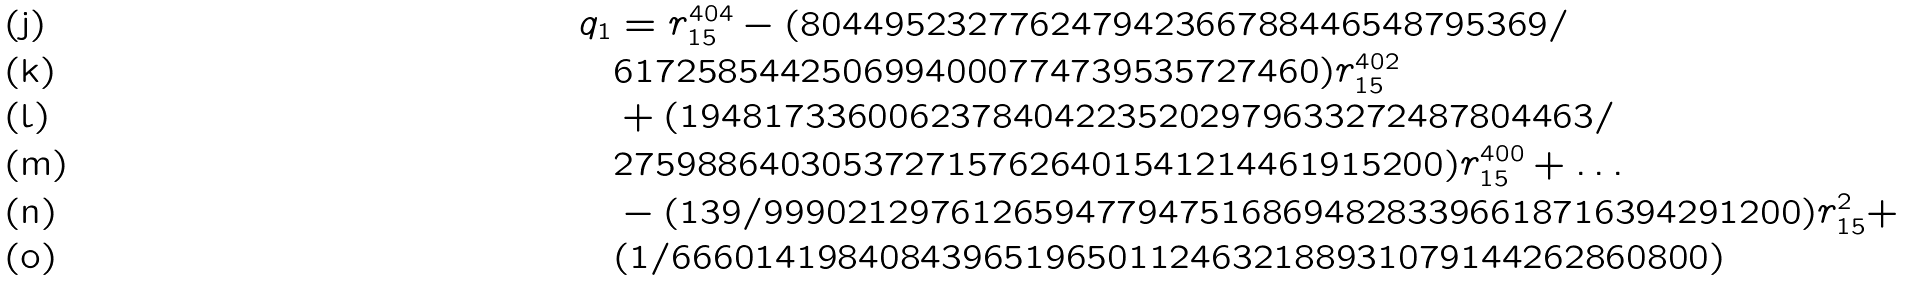<formula> <loc_0><loc_0><loc_500><loc_500>q _ { 1 } & = r _ { 1 5 } ^ { 4 0 4 } - ( 8 0 4 4 9 5 2 3 2 7 7 6 2 4 7 9 4 2 3 6 6 7 8 8 4 4 6 5 4 8 7 9 5 3 6 9 / \\ & 6 1 7 2 5 8 5 4 4 2 5 0 6 9 9 4 0 0 0 7 7 4 7 3 9 5 3 5 7 2 7 4 6 0 ) r _ { 1 5 } ^ { 4 0 2 } \\ & + ( 1 9 4 8 1 7 3 3 6 0 0 6 2 3 7 8 4 0 4 2 2 3 5 2 0 2 9 7 9 6 3 3 2 7 2 4 8 7 8 0 4 4 6 3 / \\ & 2 7 5 9 8 8 6 4 0 3 0 5 3 7 2 7 1 5 7 6 2 6 4 0 1 5 4 1 2 1 4 4 6 1 9 1 5 2 0 0 ) r _ { 1 5 } ^ { 4 0 0 } + \dots \\ & - ( 1 3 9 / 9 9 9 0 2 1 2 9 7 6 1 2 6 5 9 4 7 7 9 4 7 5 1 6 8 6 9 4 8 2 8 3 3 9 6 6 1 8 7 1 6 3 9 4 2 9 1 2 0 0 ) r _ { 1 5 } ^ { 2 } + \\ & ( 1 / 6 6 6 0 1 4 1 9 8 4 0 8 4 3 9 6 5 1 9 6 5 0 1 1 2 4 6 3 2 1 8 8 9 3 1 0 7 9 1 4 4 2 6 2 8 6 0 8 0 0 )</formula> 